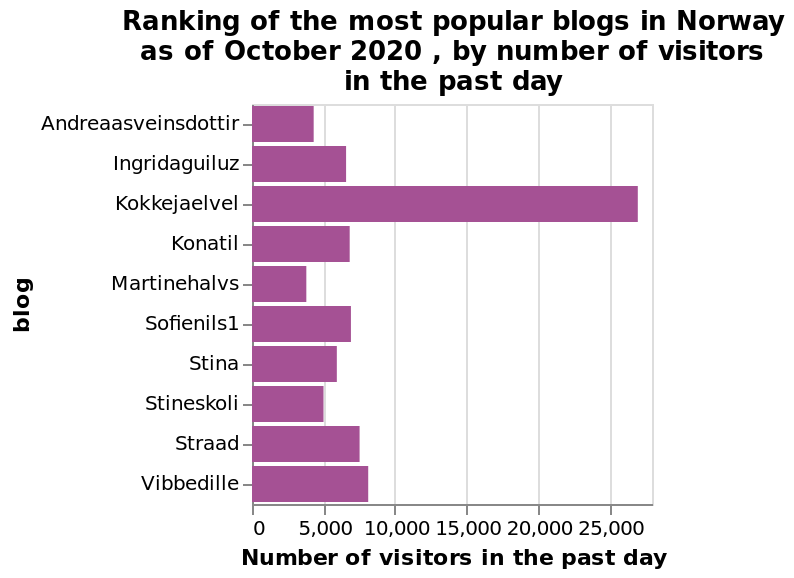<image>
What is the highest number of visits received by any blogger in the data set? The highest number of visits received by any blogger in the data set is around 25K visits. What does the y-axis represent in the bar plot? The y-axis represents the blogs in the bar plot. What is the time period for which the number of visitors is shown? The number of visitors in the past day is shown in the bar plot. 